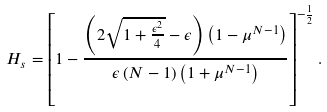<formula> <loc_0><loc_0><loc_500><loc_500>H _ { s } = \left [ 1 - \frac { \left ( 2 \sqrt { 1 + \frac { \epsilon ^ { 2 } } 4 } - \epsilon \right ) \left ( 1 - \mu ^ { N - 1 } \right ) } { \epsilon \left ( N - 1 \right ) \left ( 1 + \mu ^ { N - 1 } \right ) } \right ] ^ { - \frac { 1 } { 2 } } .</formula> 